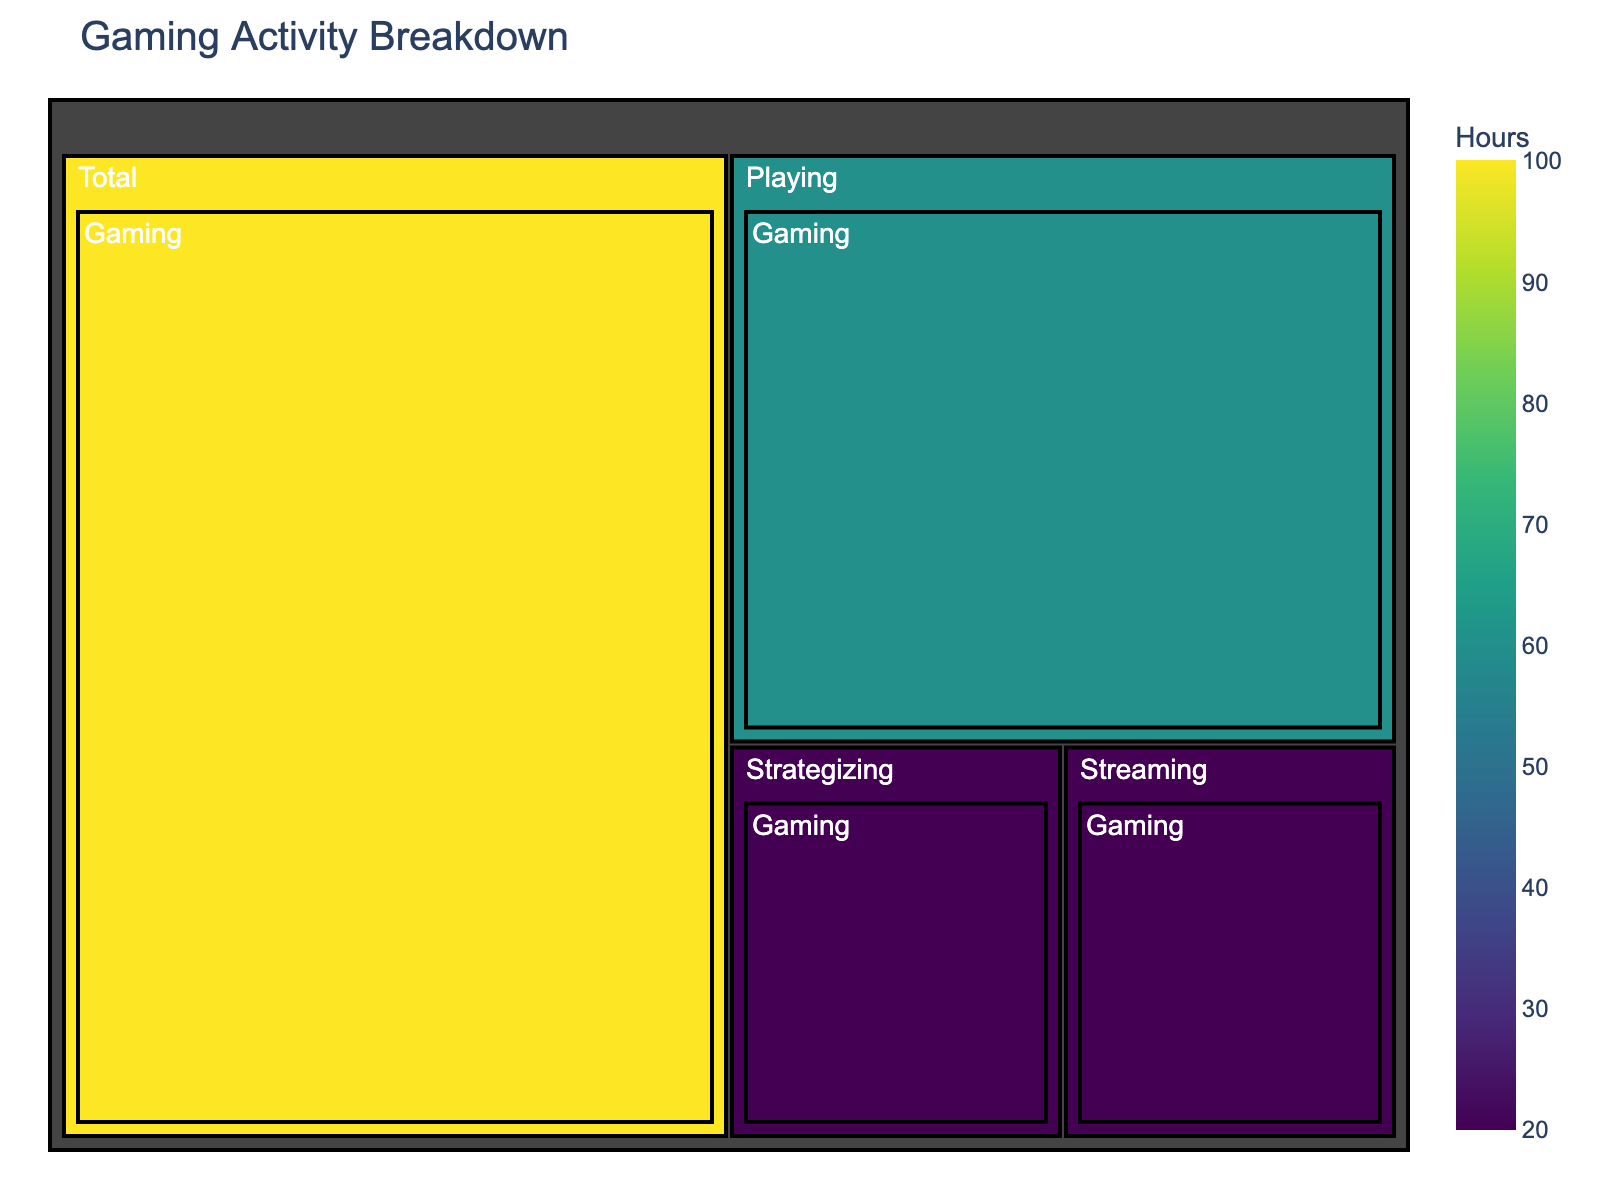what is the title of the treemap? The title of the treemap is located at the top of the figure. It provides an overview of what the figure represents.
Answer: Gaming Activity Breakdown How many hours are spent on streaming? Locate the box representing streaming in the treemap and read the value inside.
Answer: 20 Which activity takes up the most hours? Compare the size of the boxes representing each activity. The largest box corresponds to the activity with the most hours.
Answer: Playing What is the combined total of hours spent on streaming and strategizing? Sum the hours from the streaming and strategizing boxes: 20 + 20 = 40
Answer: 40 How does the time spent playing compare to the time spent streaming? The hours spent playing (60) are compared to the hours spent streaming (20). Playing has more hours.
Answer: Playing has more hours What percentage of the total time is spent strategizing? Calculate the fraction of total hours spent on strategizing (20) out of the total time (100) and then multiply by 100 to get the percentage: (20/100) * 100 = 20%
Answer: 20% Which category has the smallest number of hours? Identify the smallest box in the treemap, which corresponds to the category with the fewest hours.
Answer: Streaming and Strategizing What is the difference in time spent between the largest and smallest activities? Subtract the hours of the smallest activity (streaming or strategizing, 20) from the hours of the largest activity (playing, 60): 60 - 20 = 40
Answer: 40 How are the colors used to represent different hours? Observe the color gradient in the treemap, typically ranging from a lighter color for fewer hours to a darker color for more hours, using the Viridis scale in this case.
Answer: Darker colors represent more hours What do the white texts on the tiles indicate? The white texts on the tiles indicate the label or name of each activity category along with the number of hours.
Answer: Label and hours 